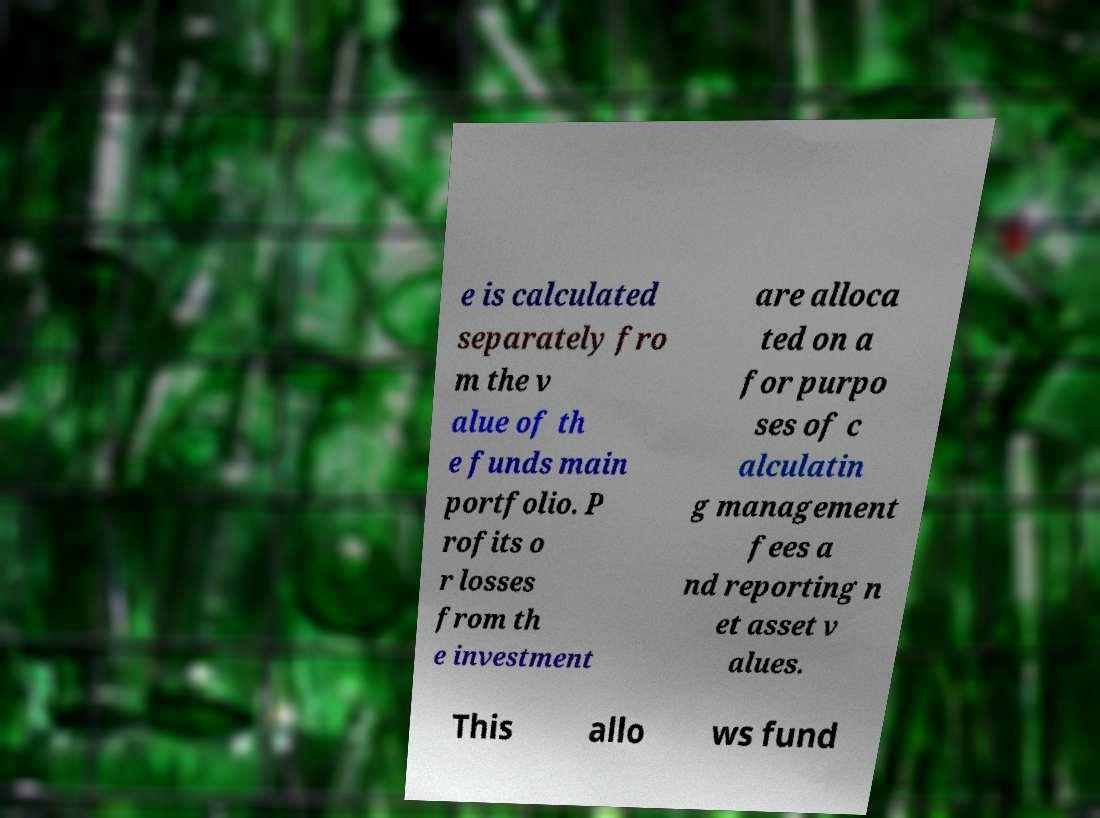Please read and relay the text visible in this image. What does it say? e is calculated separately fro m the v alue of th e funds main portfolio. P rofits o r losses from th e investment are alloca ted on a for purpo ses of c alculatin g management fees a nd reporting n et asset v alues. This allo ws fund 